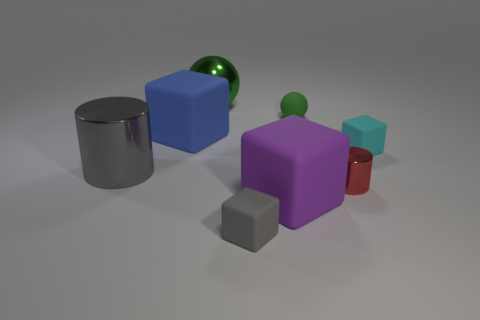Add 2 big purple matte blocks. How many objects exist? 10 Subtract all red cubes. Subtract all yellow balls. How many cubes are left? 4 Subtract all spheres. How many objects are left? 6 Add 6 small gray things. How many small gray things exist? 7 Subtract 1 gray cylinders. How many objects are left? 7 Subtract all small blocks. Subtract all gray rubber cylinders. How many objects are left? 6 Add 5 large purple objects. How many large purple objects are left? 6 